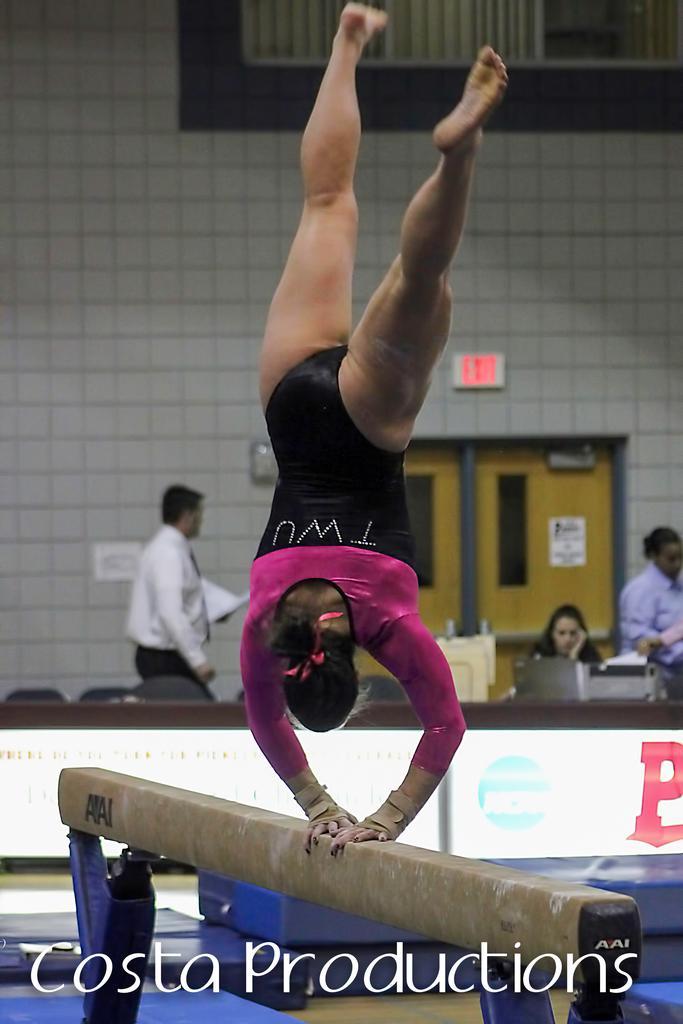Please provide a concise description of this image. In this picture we can see a woman on a balance beam and in the background we can see some people, doors, wall, curtains. 